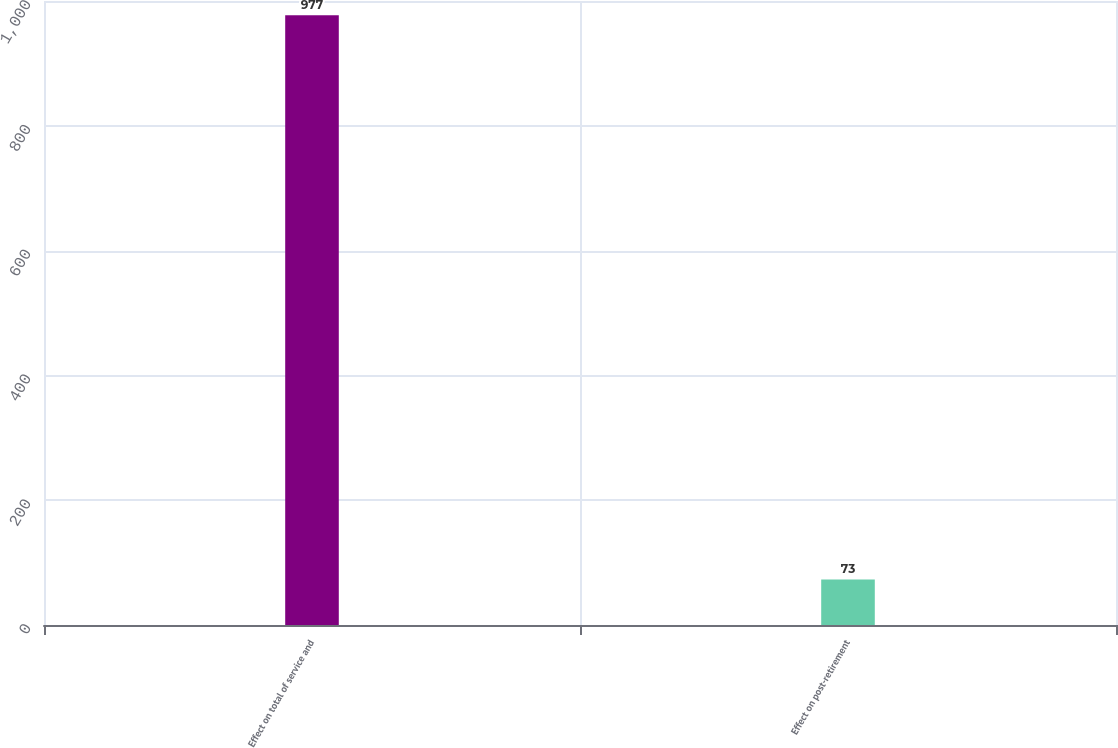<chart> <loc_0><loc_0><loc_500><loc_500><bar_chart><fcel>Effect on total of service and<fcel>Effect on post-retirement<nl><fcel>977<fcel>73<nl></chart> 